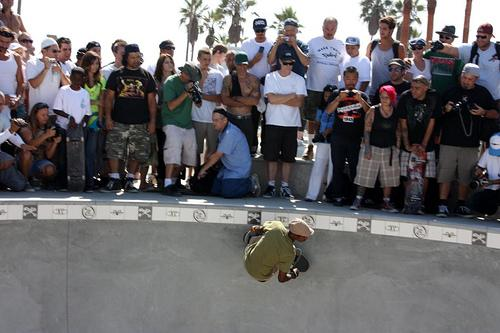What style of skateboarding is this? Please explain your reasoning. vert. A skateboarder is on a surface with a steep incline. vert is short for vertical which refers to the incline a skater is doing a trick on. 